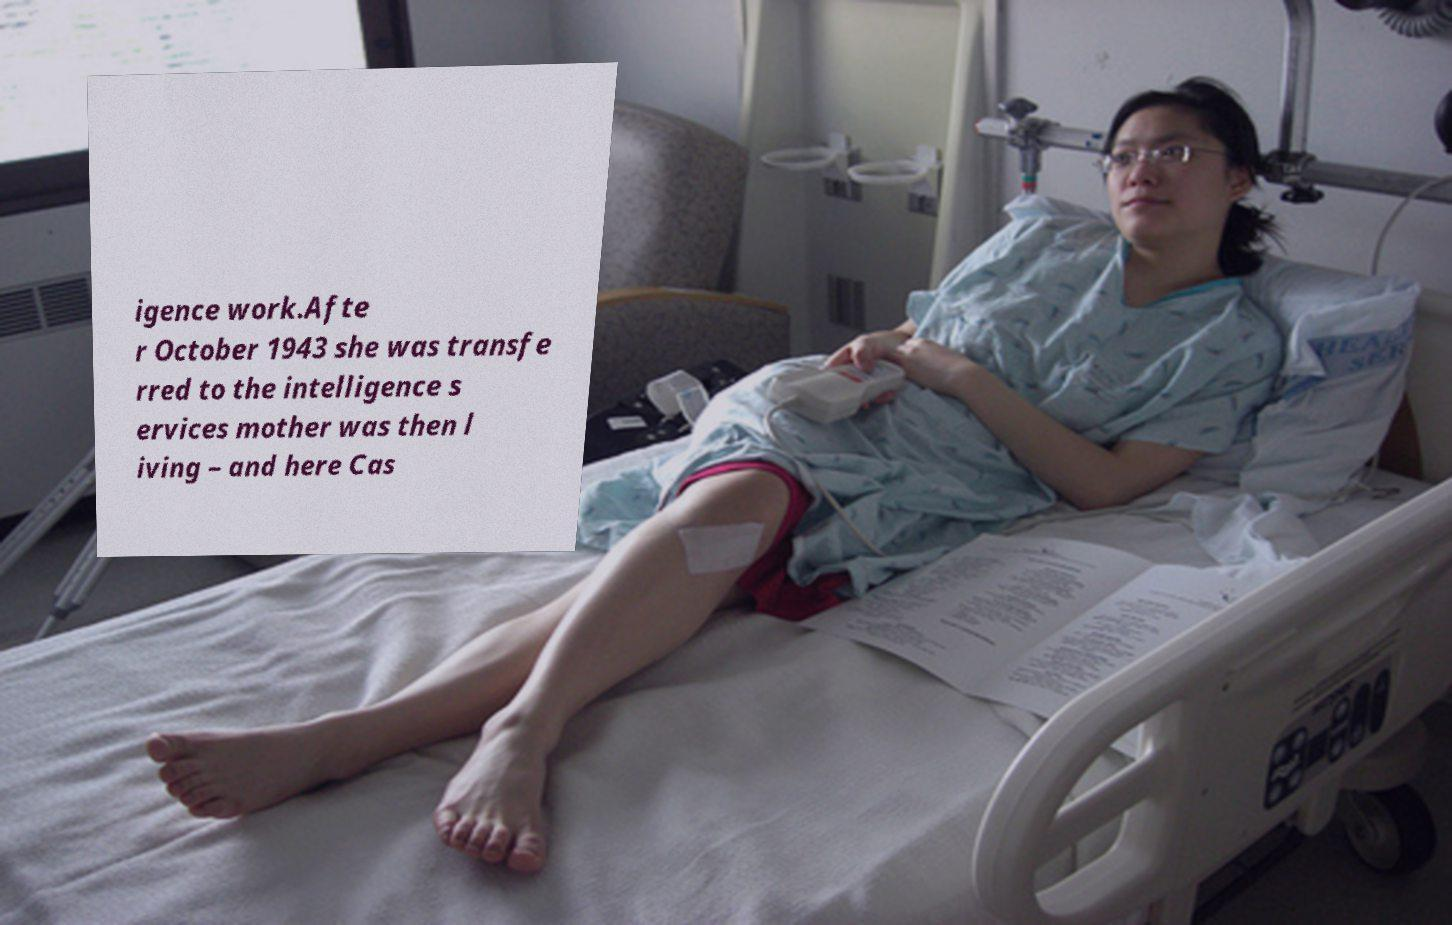For documentation purposes, I need the text within this image transcribed. Could you provide that? igence work.Afte r October 1943 she was transfe rred to the intelligence s ervices mother was then l iving – and here Cas 